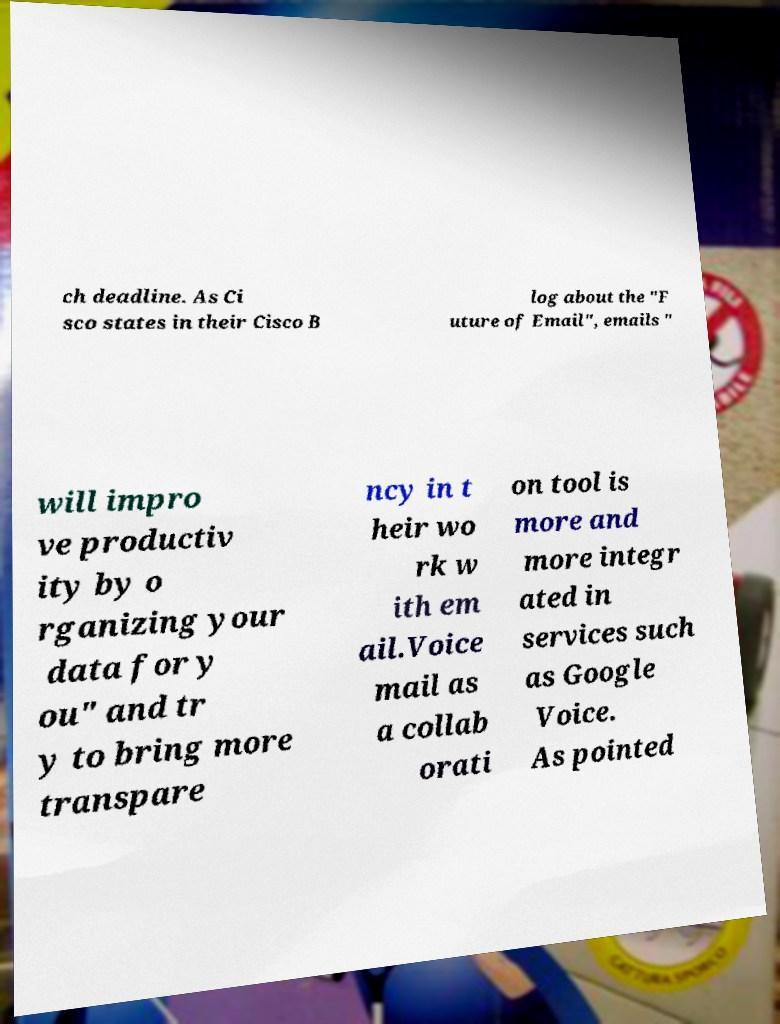There's text embedded in this image that I need extracted. Can you transcribe it verbatim? ch deadline. As Ci sco states in their Cisco B log about the "F uture of Email", emails " will impro ve productiv ity by o rganizing your data for y ou" and tr y to bring more transpare ncy in t heir wo rk w ith em ail.Voice mail as a collab orati on tool is more and more integr ated in services such as Google Voice. As pointed 